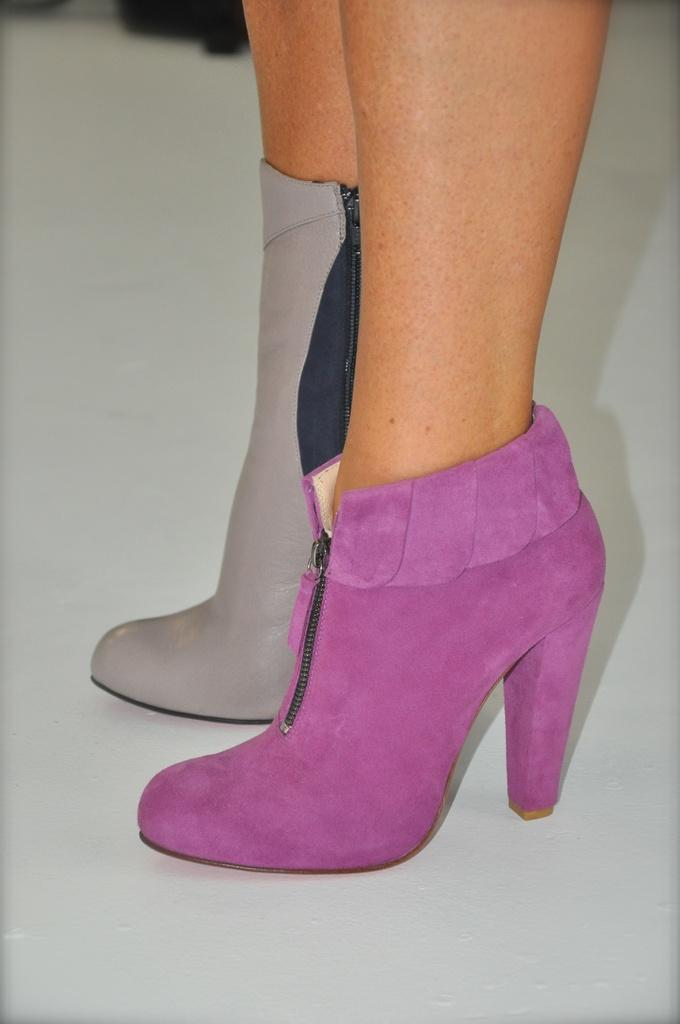Who or what can be seen in the image? There is a person in the image. What type of footwear is the person wearing? The person is wearing different color boots. What part of the person's body is visible in the image? The person's legs are visible in the image. What surface is the person standing on? The person is standing on the floor. Can you describe the background of the image? There is a black color object in the background of the image. How many trucks are visible in the image? There are no trucks present in the image. What type of marble is used for the floor in the image? The image does not show the floor material, so it cannot be determined if marble is used. 